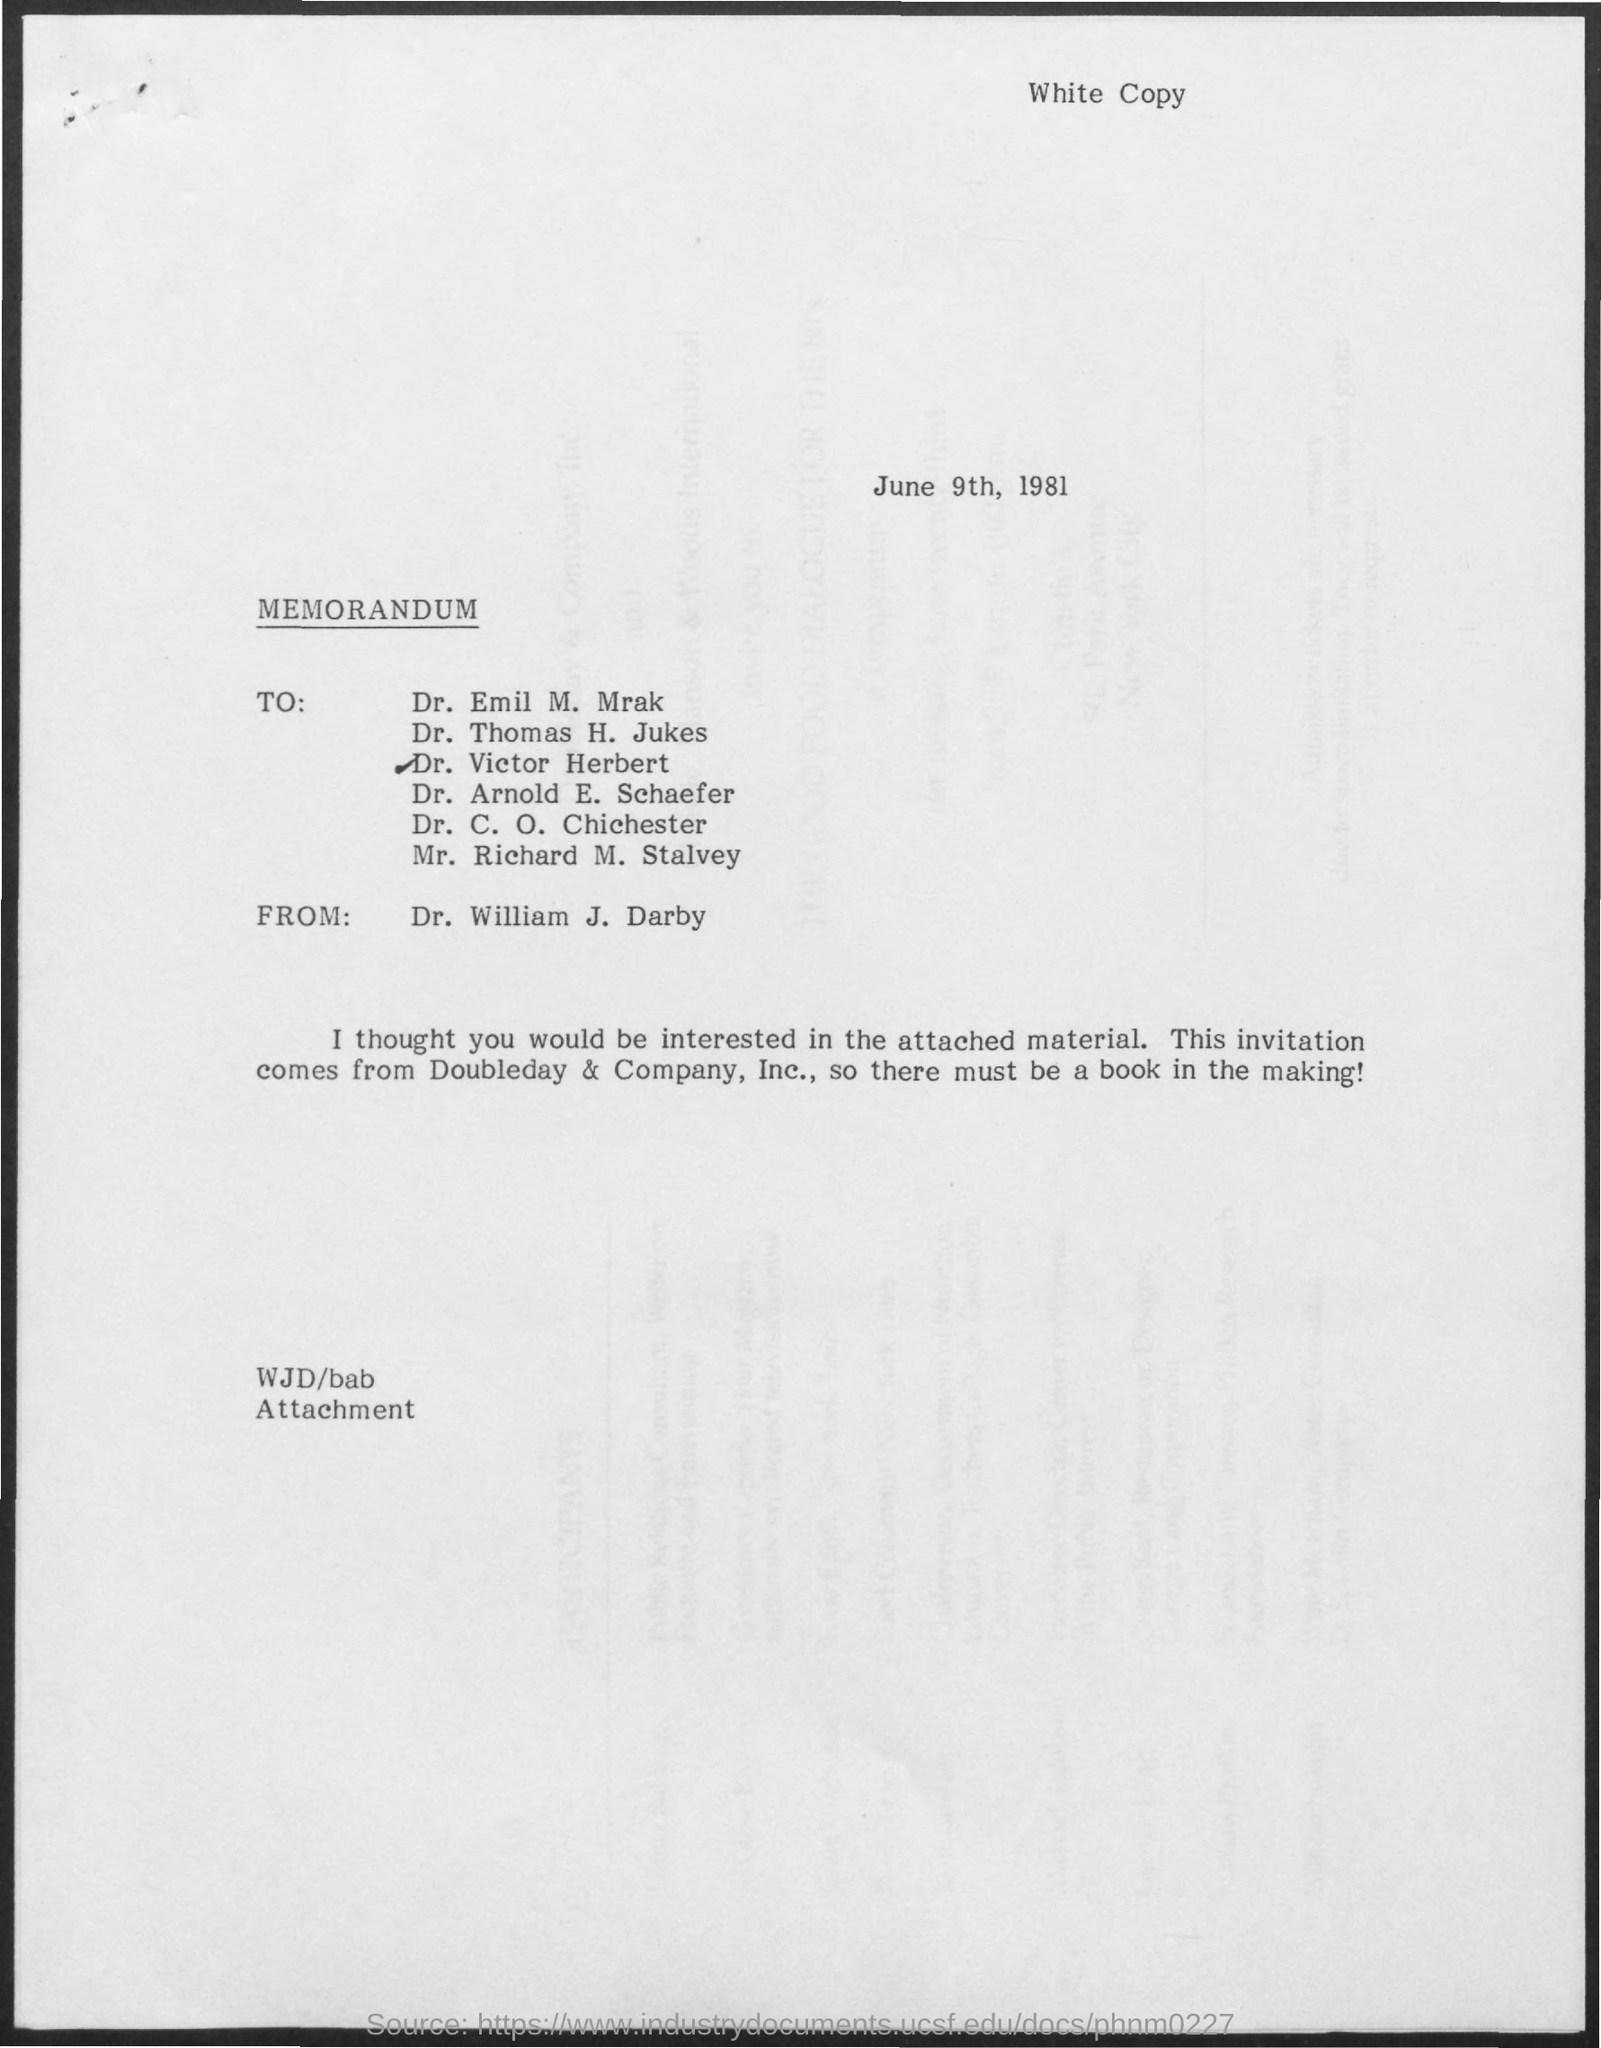What is the date mentioned in the given page ?
Your response must be concise. June 9th, 1981. From whom the memorandum was sent ?
Offer a terse response. Dr. William J. Darby. 